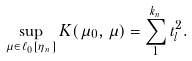<formula> <loc_0><loc_0><loc_500><loc_500>\sup _ { \mu \in \ell _ { 0 } [ \eta _ { n } ] } K ( \mu _ { 0 } , \mu ) = \sum _ { 1 } ^ { k _ { n } } t _ { l } ^ { 2 } .</formula> 